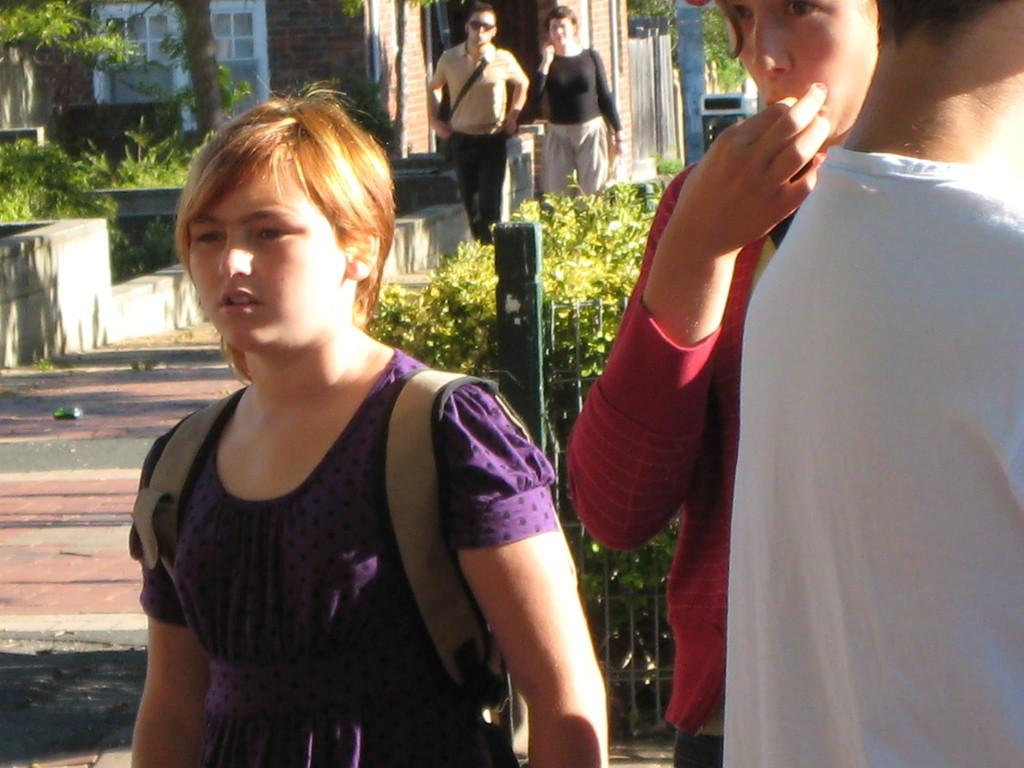What are the people in the image doing? The people in the image are standing on the footpath. What are the people carrying? The people are carrying bags. What can be seen on the ground in the image? There are plants on the ground. What is visible in the background of the image? There are buildings and trees in the background. What type of coach can be seen driving past the people in the image? There is no coach visible in the image; it only shows people standing on the footpath and the surrounding environment. How many toes are visible on the people in the image? The image does not show the toes of the people, so it is impossible to determine the number of visible toes. 